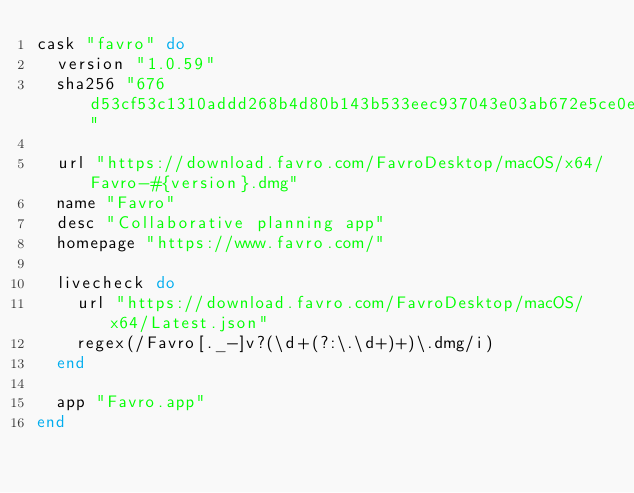Convert code to text. <code><loc_0><loc_0><loc_500><loc_500><_Ruby_>cask "favro" do
  version "1.0.59"
  sha256 "676d53cf53c1310addd268b4d80b143b533eec937043e03ab672e5ce0eb7d50e"

  url "https://download.favro.com/FavroDesktop/macOS/x64/Favro-#{version}.dmg"
  name "Favro"
  desc "Collaborative planning app"
  homepage "https://www.favro.com/"

  livecheck do
    url "https://download.favro.com/FavroDesktop/macOS/x64/Latest.json"
    regex(/Favro[._-]v?(\d+(?:\.\d+)+)\.dmg/i)
  end

  app "Favro.app"
end
</code> 